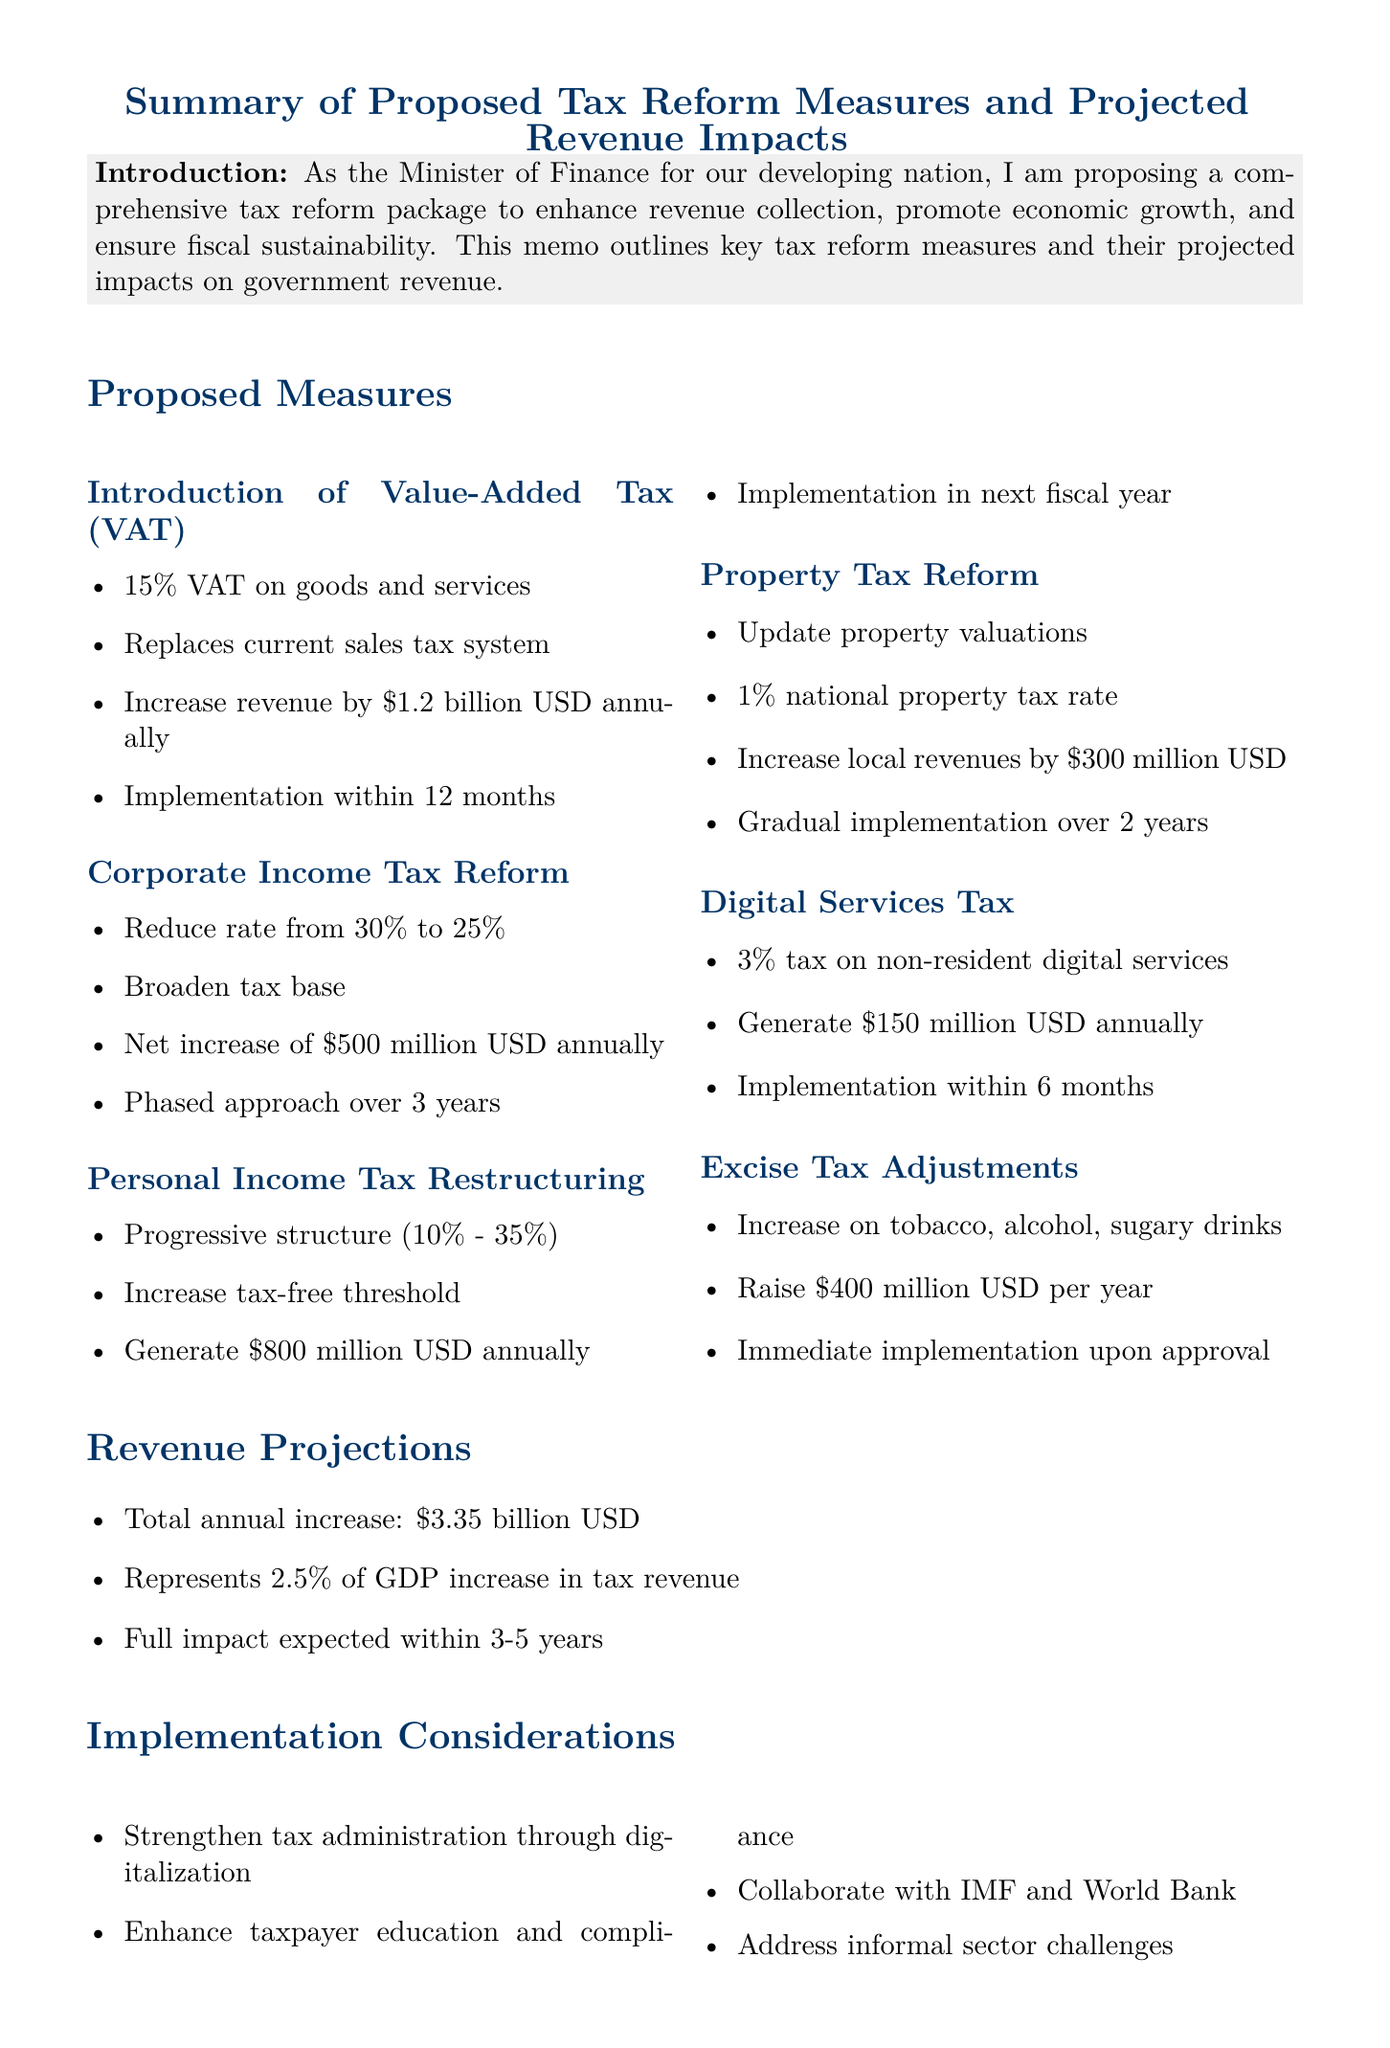What is the proposed VAT rate? The proposed VAT rate is mentioned explicitly in the document under the VAT measure.
Answer: 15% How much revenue will the corporate income tax reform generate? The projected revenue impact for corporate income tax reform is detailed in its respective section.
Answer: $500 million USD What is the projected total annual revenue increase? The document provides a summary of the total annual increase in revenue in the revenue projections section.
Answer: $3.35 billion USD What is the implementation timeline for the Digital Services Tax? The implementation timeline for the Digital Services Tax is stated in its description.
Answer: Within 6 months What is the main objective of the tax reform package? The objective is summarized in the introduction of the document and encapsulates the goal of the reforms.
Answer: Enhance revenue collection How many years will the corporate income tax reform be phased over? The duration over which the corporate income tax reform will be implemented is outlined in the proposed measures section.
Answer: 3 years What tax rate will property tax be set at? The document specifies the national property tax rate proposed in the tax reform measures.
Answer: 1% What is one of the implementation considerations mentioned? The document lists several implementation considerations, which can be extracted from that section.
Answer: Strengthening tax administration What are the next steps following the proposed reforms? The next steps following the proposals are detailed in the conclusion section of the memo.
Answer: Seek cabinet approval 